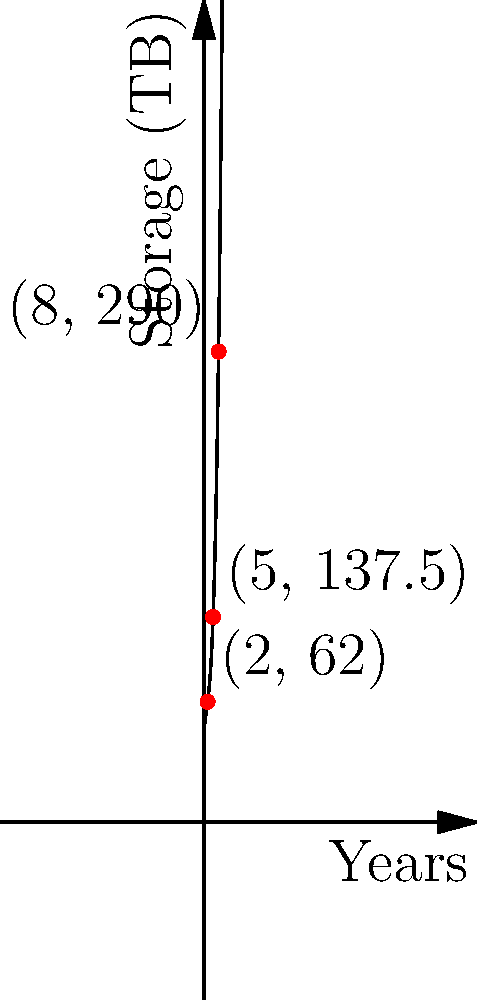As a biobank coordinator, you've been tracking the genetic data storage needs over the past 8 years. The graph shows a polynomial model of the storage requirements in terabytes (TB) over time. Given that the model follows the equation $f(x) = 0.5x^3 - 2x^2 + 10x + 50$, where $x$ represents years and $f(x)$ represents storage in TB, what will be the approximate storage requirement in 10 years? To find the storage requirement in 10 years, we need to evaluate the polynomial function at $x = 10$. Let's follow these steps:

1. The given polynomial function is:
   $f(x) = 0.5x^3 - 2x^2 + 10x + 50$

2. Substitute $x = 10$ into the function:
   $f(10) = 0.5(10)^3 - 2(10)^2 + 10(10) + 50$

3. Calculate each term:
   $0.5(10)^3 = 0.5 * 1000 = 500$
   $2(10)^2 = 2 * 100 = 200$
   $10(10) = 100$
   $50$ remains as is

4. Combine the terms:
   $f(10) = 500 - 200 + 100 + 50$

5. Calculate the final result:
   $f(10) = 450$

Therefore, in 10 years, the storage requirement will be approximately 450 TB.
Answer: 450 TB 